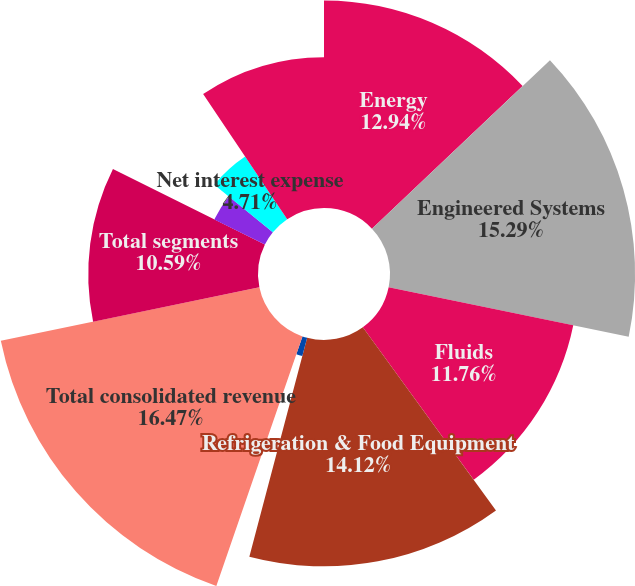Convert chart to OTSL. <chart><loc_0><loc_0><loc_500><loc_500><pie_chart><fcel>Energy<fcel>Engineered Systems<fcel>Fluids<fcel>Refrigeration & Food Equipment<fcel>Intra-segment eliminations<fcel>Total consolidated revenue<fcel>Total segments<fcel>Corporate expense / other (1)<fcel>Net interest expense<fcel>Earnings before provision for<nl><fcel>12.94%<fcel>15.29%<fcel>11.76%<fcel>14.12%<fcel>1.18%<fcel>16.47%<fcel>10.59%<fcel>3.53%<fcel>4.71%<fcel>9.41%<nl></chart> 